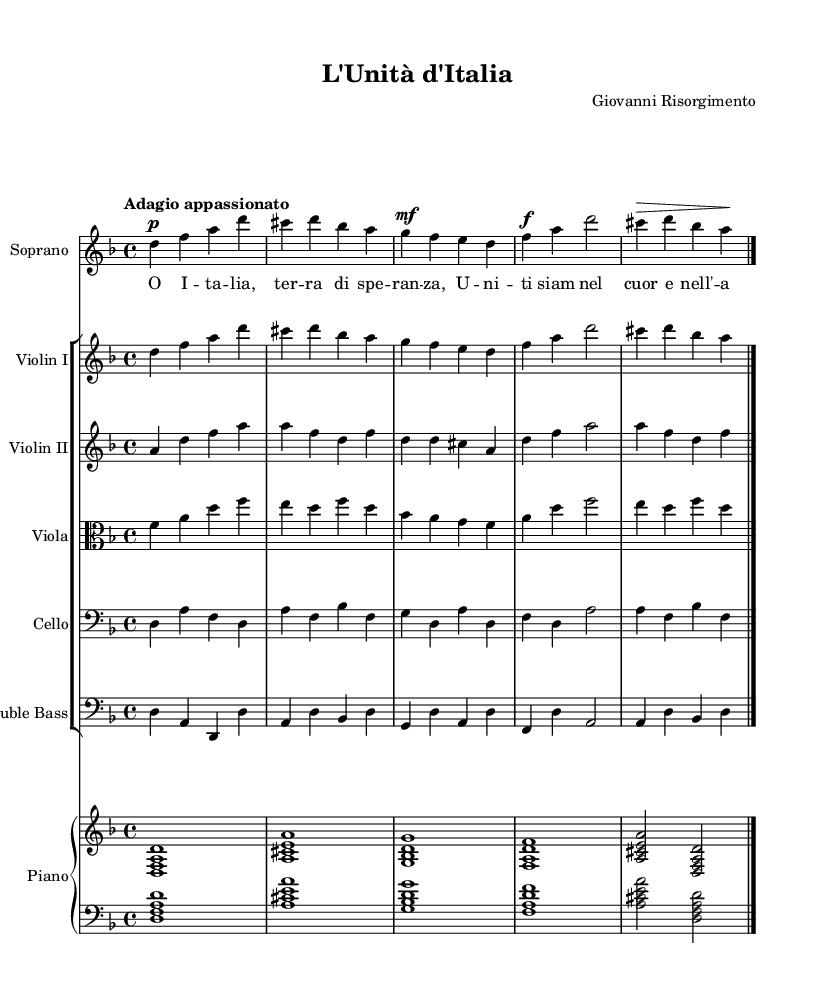What is the key signature of this music? The key signature is indicated at the beginning of the staff. In this case, it shows one flat, which corresponds to D minor.
Answer: D minor What is the time signature of the piece? The time signature is located following the key signature. It shows a "4/4" notation, meaning there are four beats in a measure and the quarter note gets one beat.
Answer: 4/4 What is the tempo marking for the piece? The tempo marking is written above the music and states "Adagio appassionato," which indicates a slow and passionate pace for the performance.
Answer: Adagio appassionato What is the name of the composer? The composer's name is found in the header section of the sheet music. Here, it clearly states "Giovanni Risorgimento" as the composer.
Answer: Giovanni Risorgimento How many instruments are in the score? By counting the staves in the score, we can see there are several: a soprano, two violins, a viola, a cello, a double bass, and a piano, totaling seven instruments in the score.
Answer: Seven What is the dynamic marking for the first soprano measure? The first dynamic marking for the soprano occurs at the start of the first measure, indicated as "p," which means piano or soft.
Answer: p In which era is this opera composed? The music is classified under the Romantic era, which is inferred from the style and characteristics of the piece, notably its emotional expression and thematic content related to unity and hope.
Answer: Romantic 